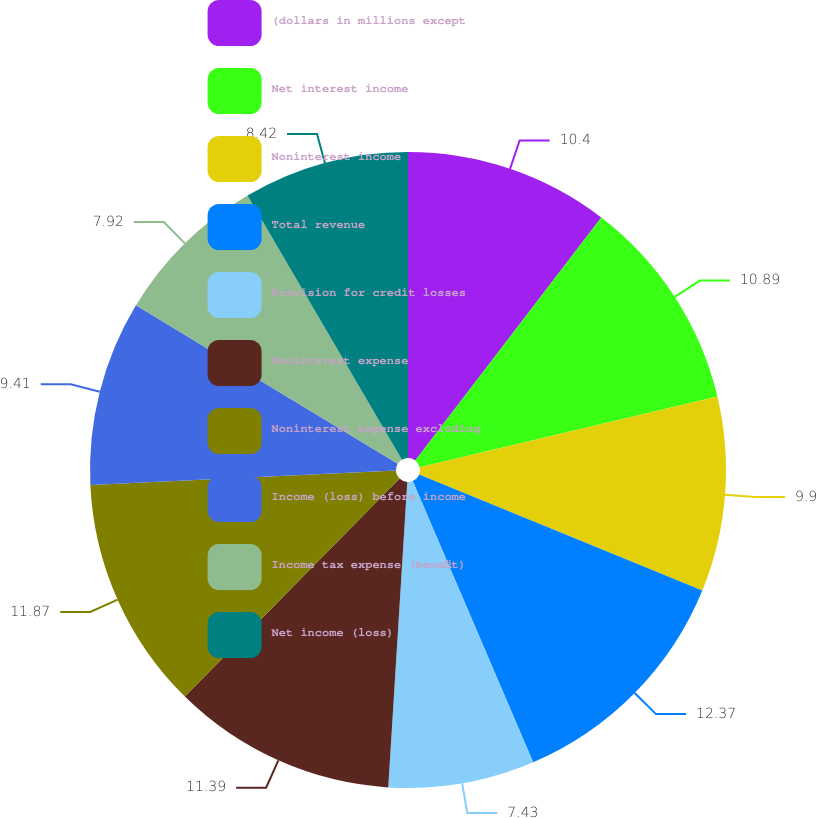<chart> <loc_0><loc_0><loc_500><loc_500><pie_chart><fcel>(dollars in millions except<fcel>Net interest income<fcel>Noninterest income<fcel>Total revenue<fcel>Provision for credit losses<fcel>Noninterest expense<fcel>Noninterest expense excluding<fcel>Income (loss) before income<fcel>Income tax expense (benefit)<fcel>Net income (loss)<nl><fcel>10.4%<fcel>10.89%<fcel>9.9%<fcel>12.38%<fcel>7.43%<fcel>11.39%<fcel>11.88%<fcel>9.41%<fcel>7.92%<fcel>8.42%<nl></chart> 